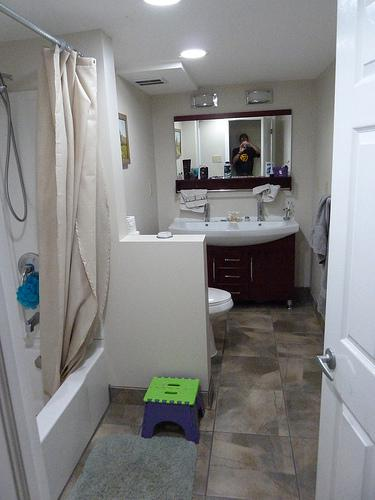Question: what is the focus?
Choices:
A. Bedroom.
B. Kitchen.
C. Bathroom.
D. Office.
Answer with the letter. Answer: C Question: what colors are the step stool?
Choices:
A. Yellow and red.
B. Blue and green.
C. Brown and black.
D. Green and purple.
Answer with the letter. Answer: D Question: where is this shot?
Choices:
A. Doorway.
B. Hallway.
C. Window.
D. Entryway.
Answer with the letter. Answer: A Question: how many animals are shown?
Choices:
A. 1.
B. 0.
C. 2.
D. 3.
Answer with the letter. Answer: B Question: how many drawers are on the bathroom cabinet?
Choices:
A. 2.
B. 4.
C. 3.
D. 5.
Answer with the letter. Answer: C 